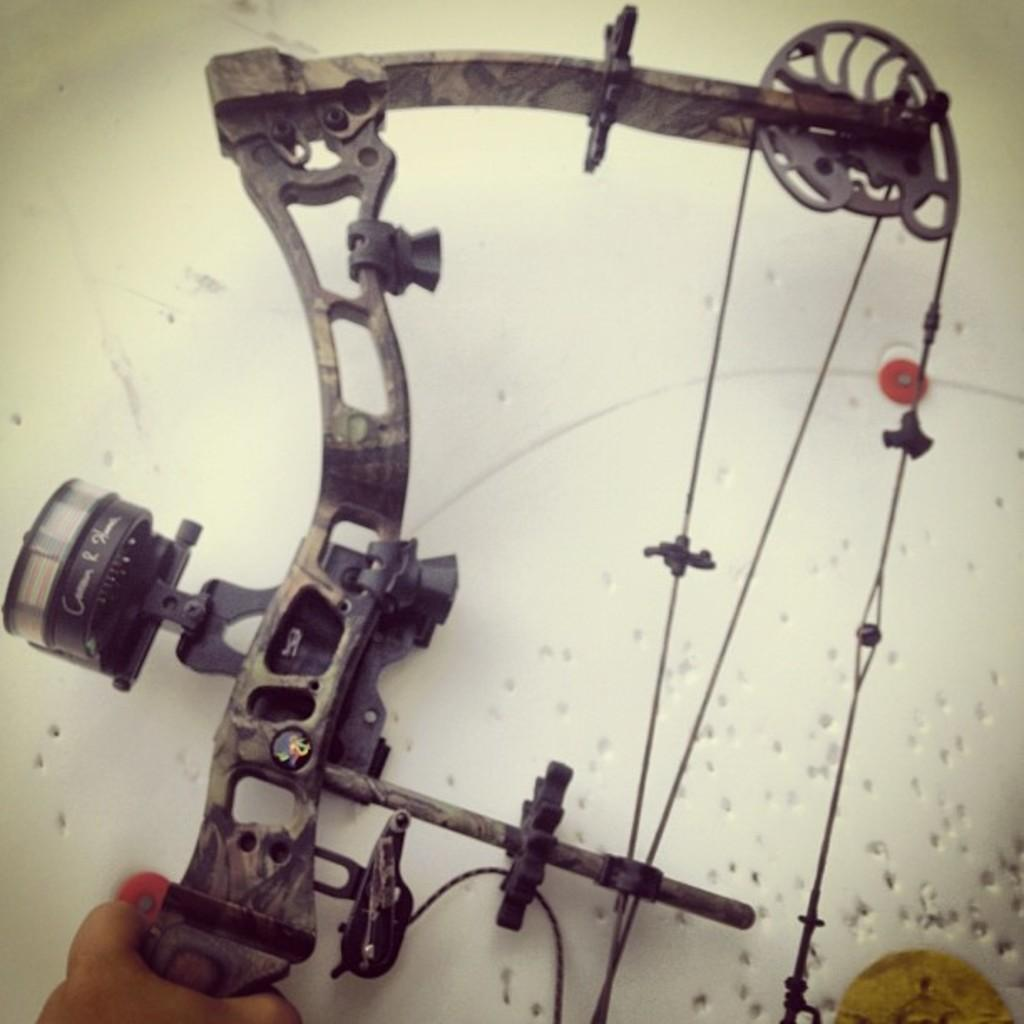What is the main object in the image? There is a machine in the image. image. Can you describe the background of the image? The background of the image is white with holes. Is there any human presence in the image? Yes, there is a person's hand visible in the image. What type of balloon is being inflated by the machine in the image? There is no balloon present in the image; it only features a machine and a white background with holes. Can you hear the person coughing in the image? The image is silent, and there is no indication of any sound, including coughing. 